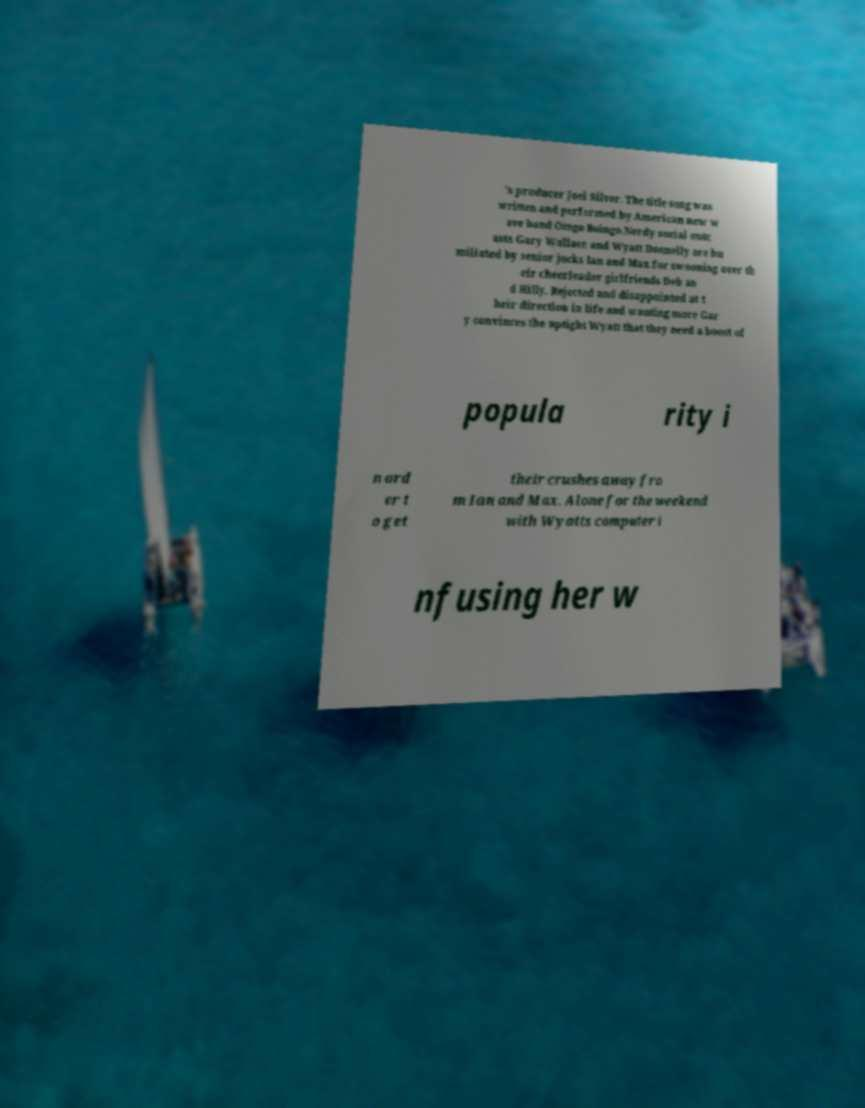I need the written content from this picture converted into text. Can you do that? 's producer Joel Silver. The title song was written and performed by American new w ave band Oingo Boingo.Nerdy social outc asts Gary Wallace and Wyatt Donnelly are hu miliated by senior jocks Ian and Max for swooning over th eir cheerleader girlfriends Deb an d Hilly. Rejected and disappointed at t heir direction in life and wanting more Gar y convinces the uptight Wyatt that they need a boost of popula rity i n ord er t o get their crushes away fro m Ian and Max. Alone for the weekend with Wyatts computer i nfusing her w 